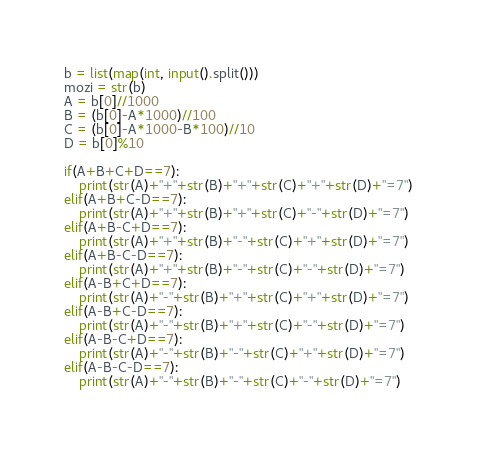<code> <loc_0><loc_0><loc_500><loc_500><_Python_>b = list(map(int, input().split()))
mozi = str(b)
A = b[0]//1000
B = (b[0]-A*1000)//100
C = (b[0]-A*1000-B*100)//10
D = b[0]%10

if(A+B+C+D==7):
    print(str(A)+"+"+str(B)+"+"+str(C)+"+"+str(D)+"=7")
elif(A+B+C-D==7):
    print(str(A)+"+"+str(B)+"+"+str(C)+"-"+str(D)+"=7")
elif(A+B-C+D==7):
    print(str(A)+"+"+str(B)+"-"+str(C)+"+"+str(D)+"=7")
elif(A+B-C-D==7):
    print(str(A)+"+"+str(B)+"-"+str(C)+"-"+str(D)+"=7")
elif(A-B+C+D==7):
    print(str(A)+"-"+str(B)+"+"+str(C)+"+"+str(D)+"=7")
elif(A-B+C-D==7):
    print(str(A)+"-"+str(B)+"+"+str(C)+"-"+str(D)+"=7")
elif(A-B-C+D==7):
    print(str(A)+"-"+str(B)+"-"+str(C)+"+"+str(D)+"=7")
elif(A-B-C-D==7):
    print(str(A)+"-"+str(B)+"-"+str(C)+"-"+str(D)+"=7")</code> 